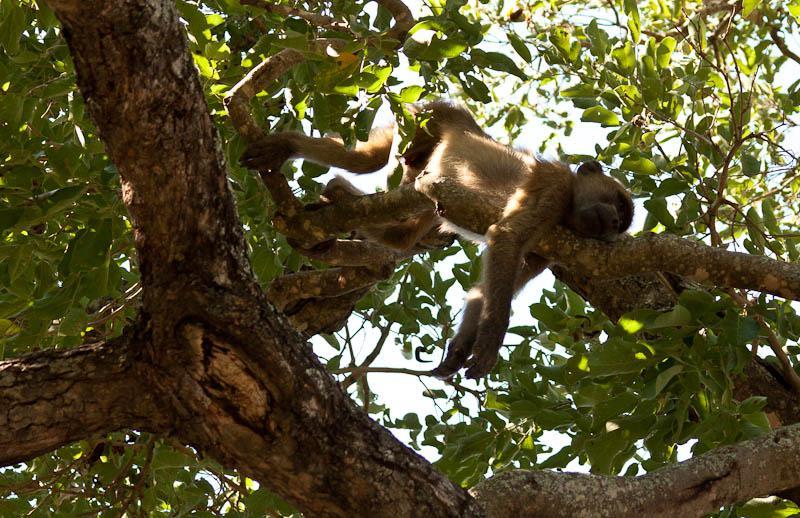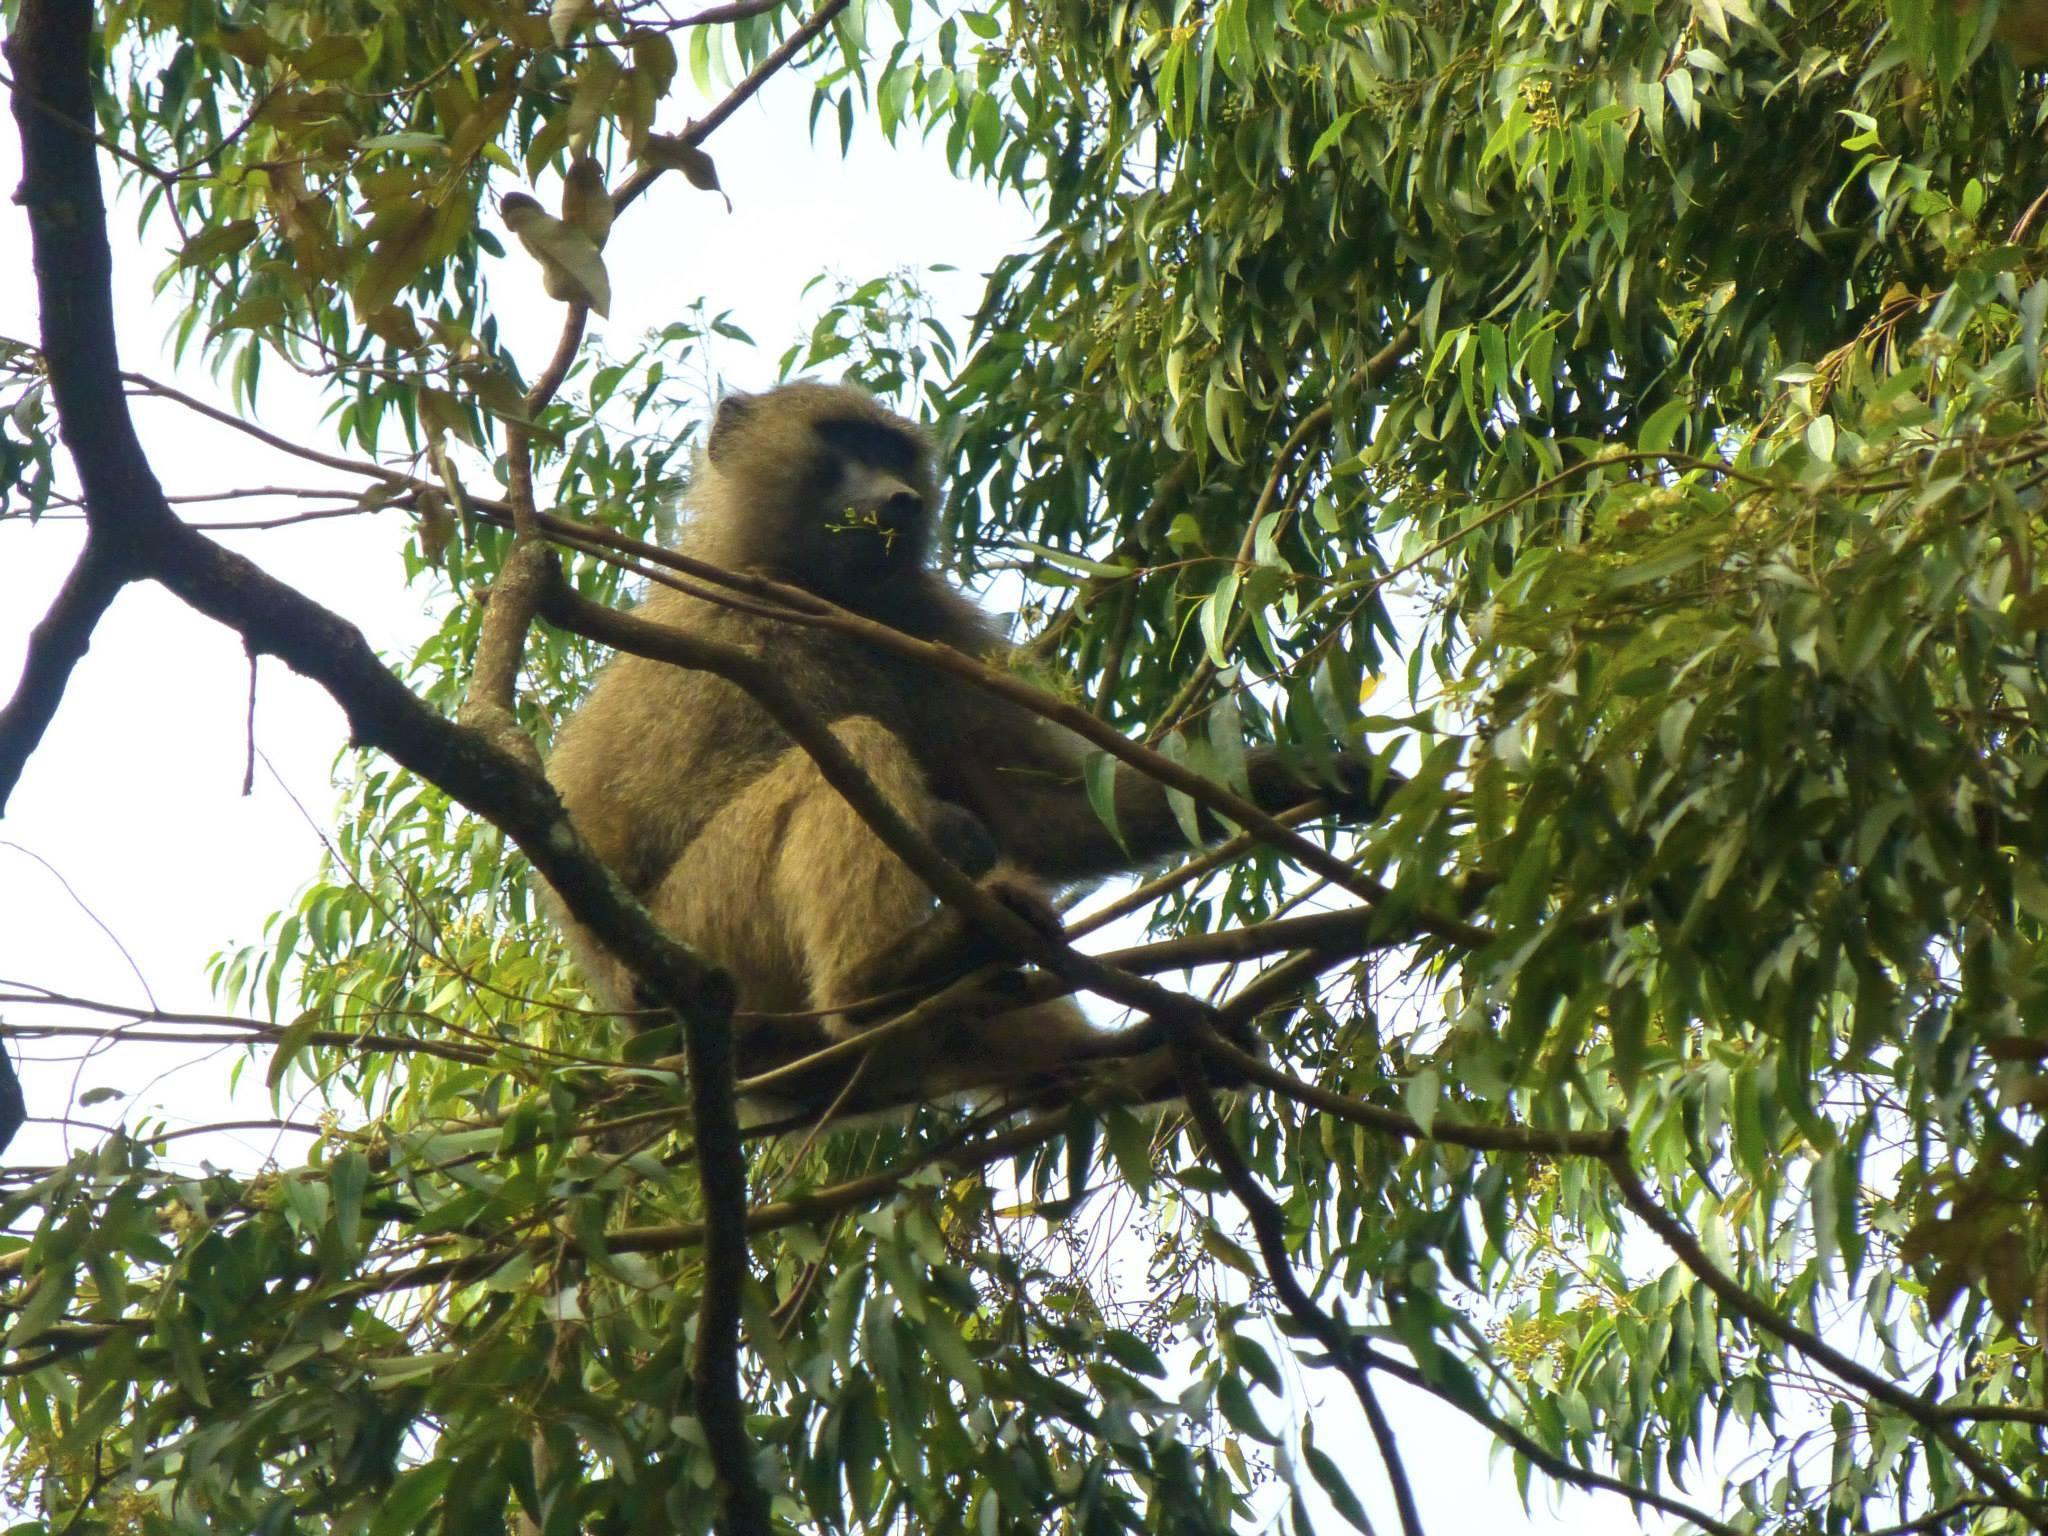The first image is the image on the left, the second image is the image on the right. Evaluate the accuracy of this statement regarding the images: "All baboons are pictured in the branches of trees, and baboons of different ages are included in the combined images.". Is it true? Answer yes or no. Yes. The first image is the image on the left, the second image is the image on the right. Assess this claim about the two images: "The monkeys in each of the images are sitting in the trees.". Correct or not? Answer yes or no. Yes. 